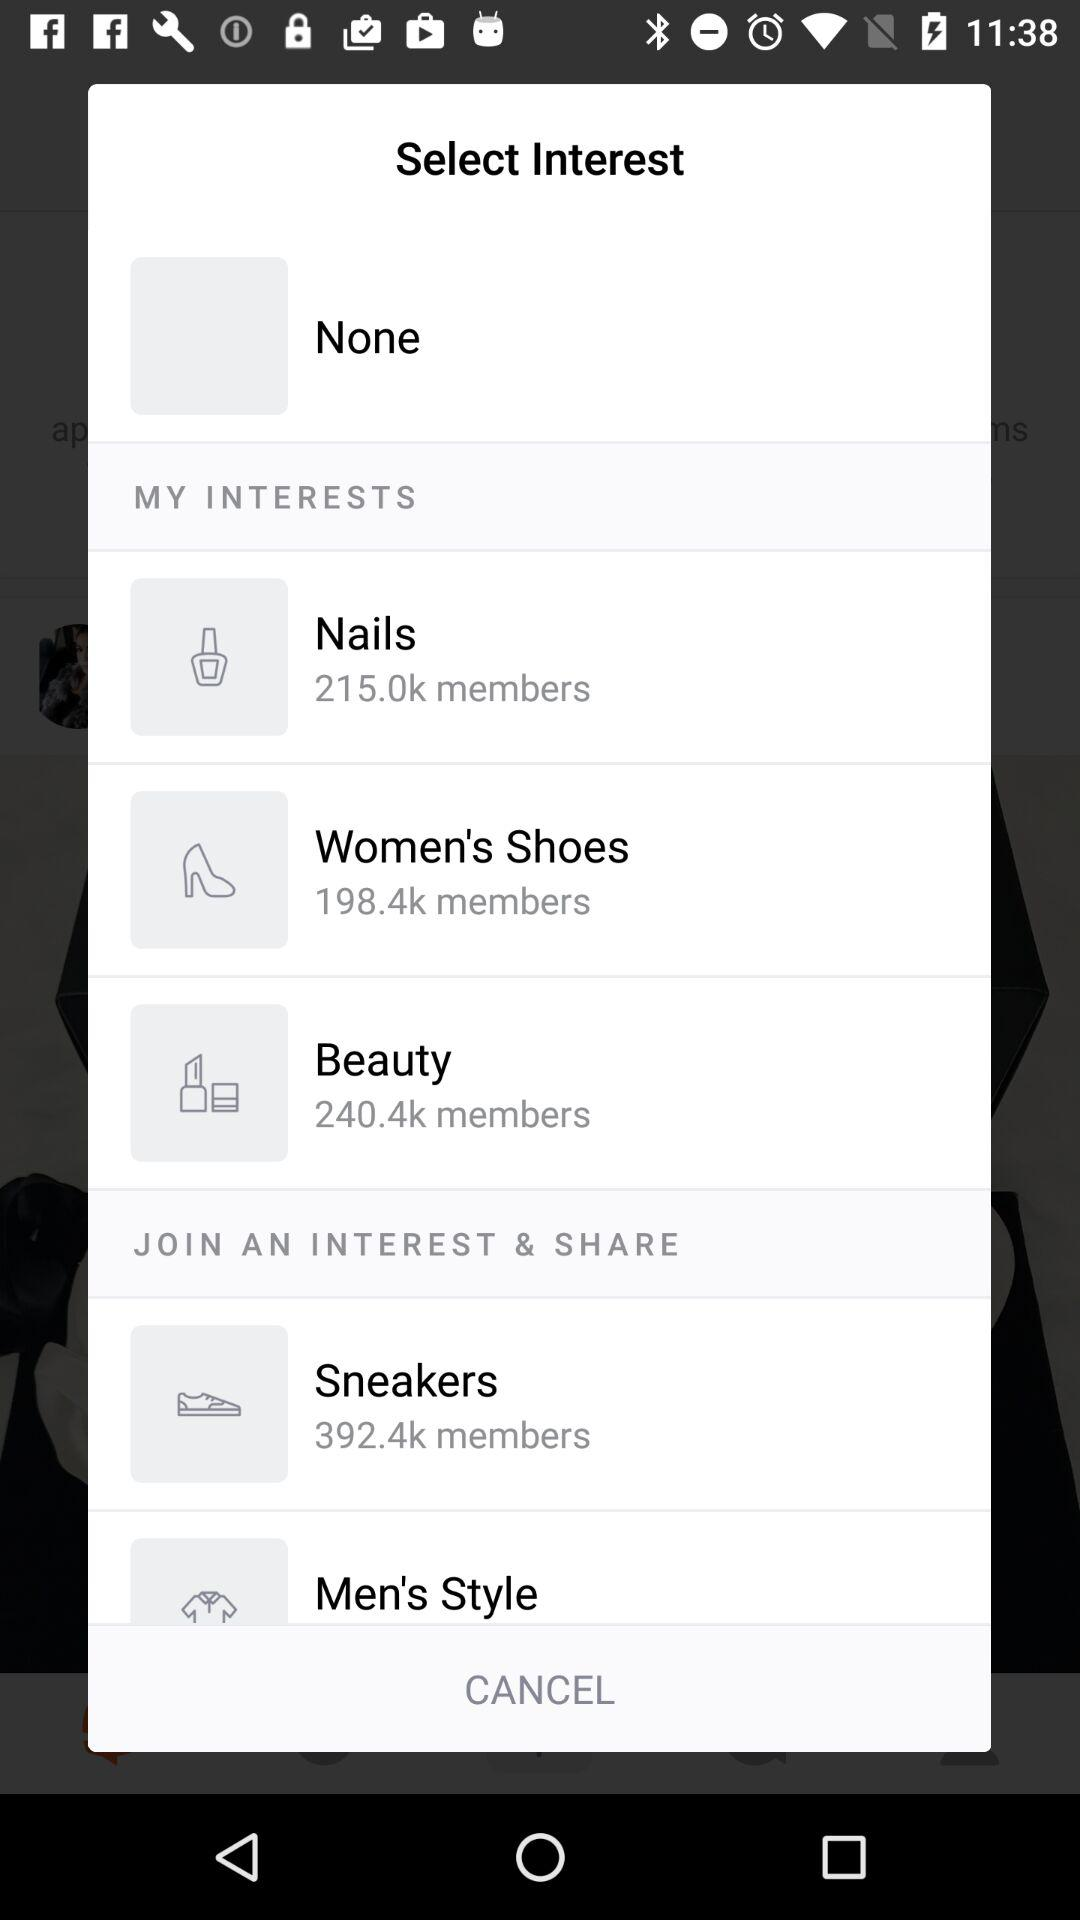What are the categories in "MY INTERESTS"? The categories in "MY INTERESTS" are "Nails", "Women's Shoes" and "Beauty". 